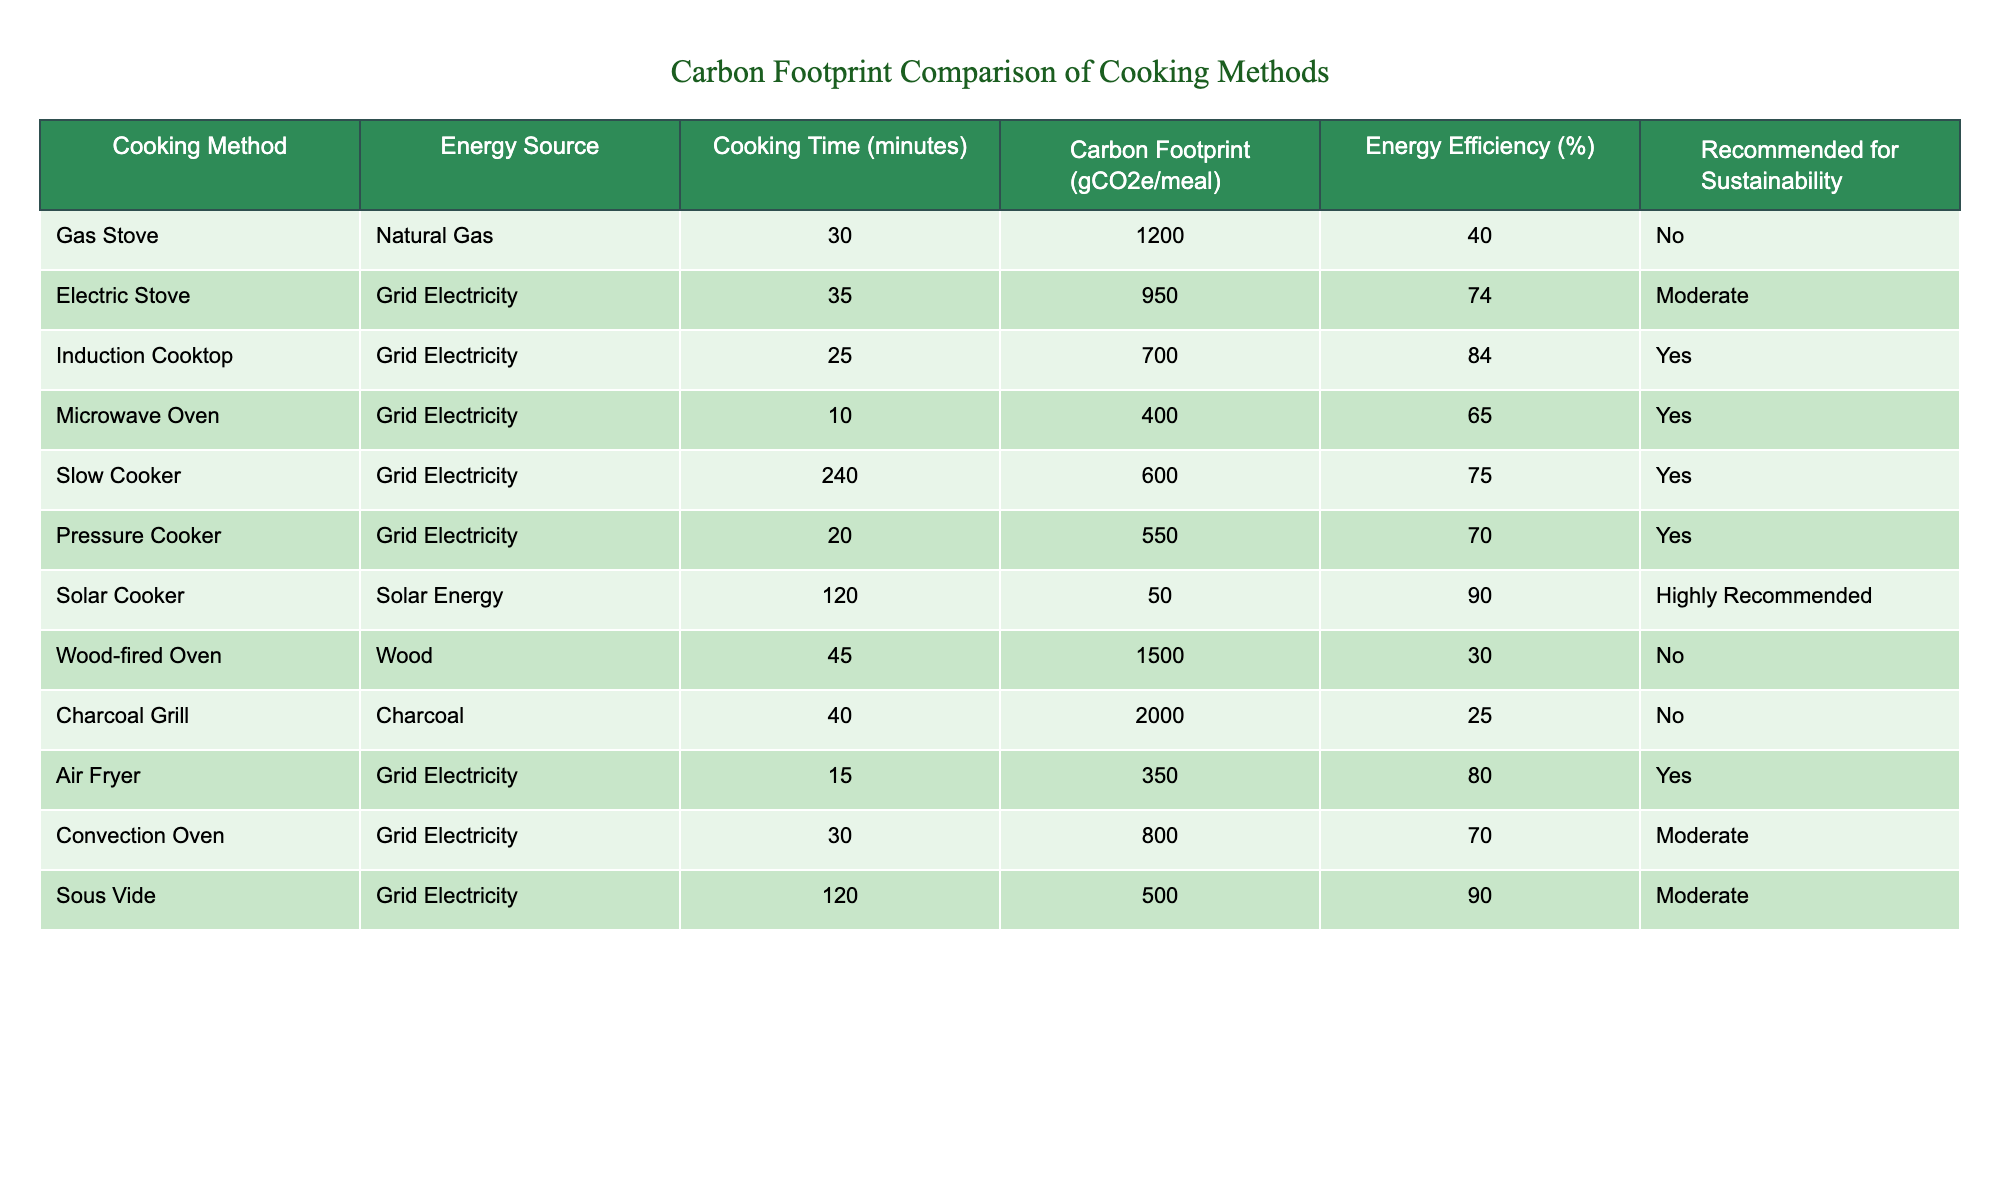What is the carbon footprint for using an induction cooktop? The table lists the carbon footprint of the induction cooktop under the "Carbon Footprint (gCO2e/meal)" column, which is 700.
Answer: 700 Which cooking method has the highest carbon footprint? By reviewing the "Carbon Footprint (gCO2e/meal)" column, the highest value is 2000 for the charcoal grill.
Answer: Charcoal Grill What is the average carbon footprint of all cooking methods that are recommended for sustainability? The recommended methods with their carbon footprints are: Induction Cooktop (700), Microwave Oven (400), Slow Cooker (600), Pressure Cooker (550), Air Fryer (350), and Solar Cooker (50). Adding these gives a total of 2700. Since there are 6 methods, the average is 2700/6 = 450.
Answer: 450 Is the energy efficiency of the solar cooker the highest among all cooking methods? The solar cooker has an energy efficiency of 90%, and by examining the "Energy Efficiency (%)" column, all other methods have lower efficiency percentages. Thus, the solar cooker is indeed the highest.
Answer: Yes Which cooking method would be the most sustainable choice based on the table? Checking the "Recommended for Sustainability" column, the solar cooker is "Highly Recommended," making it the most sustainable option.
Answer: Solar Cooker What is the difference in cooking time between using a microwave oven and a slow cooker? The cooking time for a microwave oven is listed as 10 minutes, and for a slow cooker, it is 240 minutes. The difference is 240 - 10 = 230 minutes.
Answer: 230 minutes How many cooking methods have a carbon footprint under 600 gCO2e/meal? Reviewing the "Carbon Footprint (gCO2e/meal)" column, the methods with a footprint under 600 are the microwave oven (400), slow cooker (600), pressure cooker (550), and air fryer (350). The total count is 4 methods.
Answer: 4 Which energy source is used by the pressure cooker? The table indicates the energy source for the pressure cooker is grid electricity, found in the "Energy Source" column.
Answer: Grid Electricity What is the carbon footprint difference between the gas stove and the electric stove? The gas stove's carbon footprint is 1200, while the electric stove's is 950. Calculating the difference: 1200 - 950 = 250.
Answer: 250 